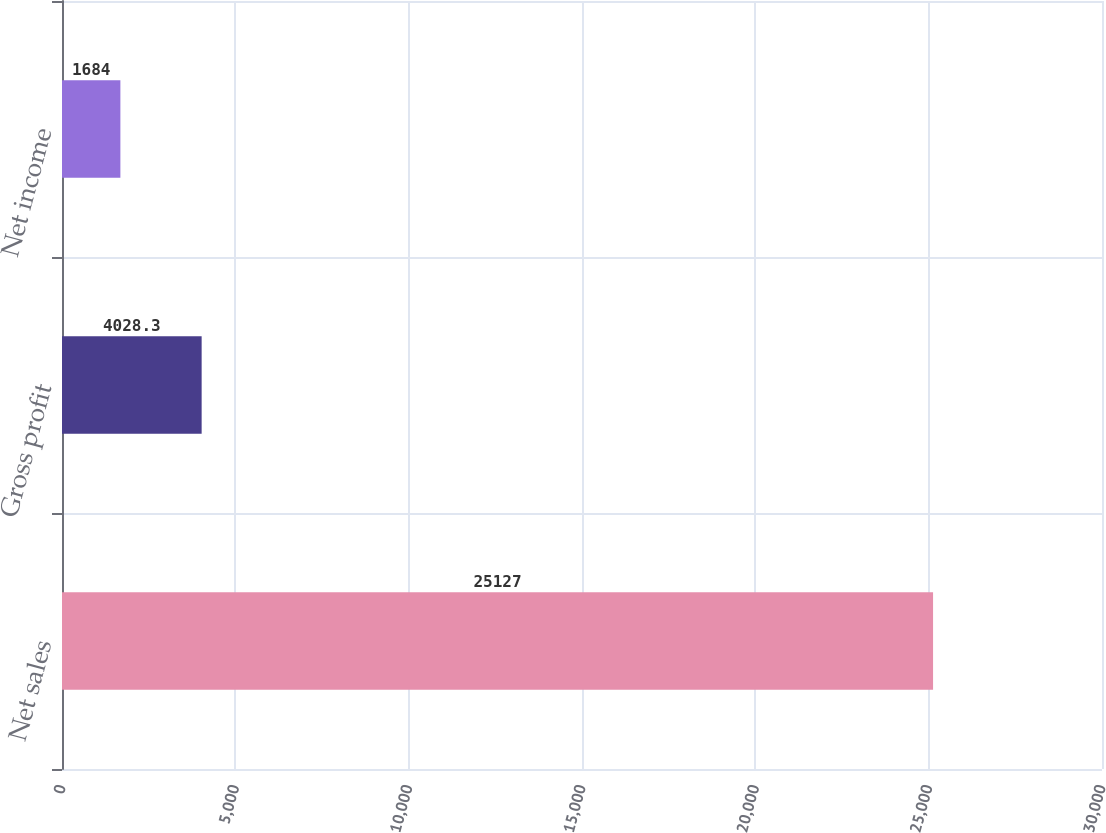<chart> <loc_0><loc_0><loc_500><loc_500><bar_chart><fcel>Net sales<fcel>Gross profit<fcel>Net income<nl><fcel>25127<fcel>4028.3<fcel>1684<nl></chart> 